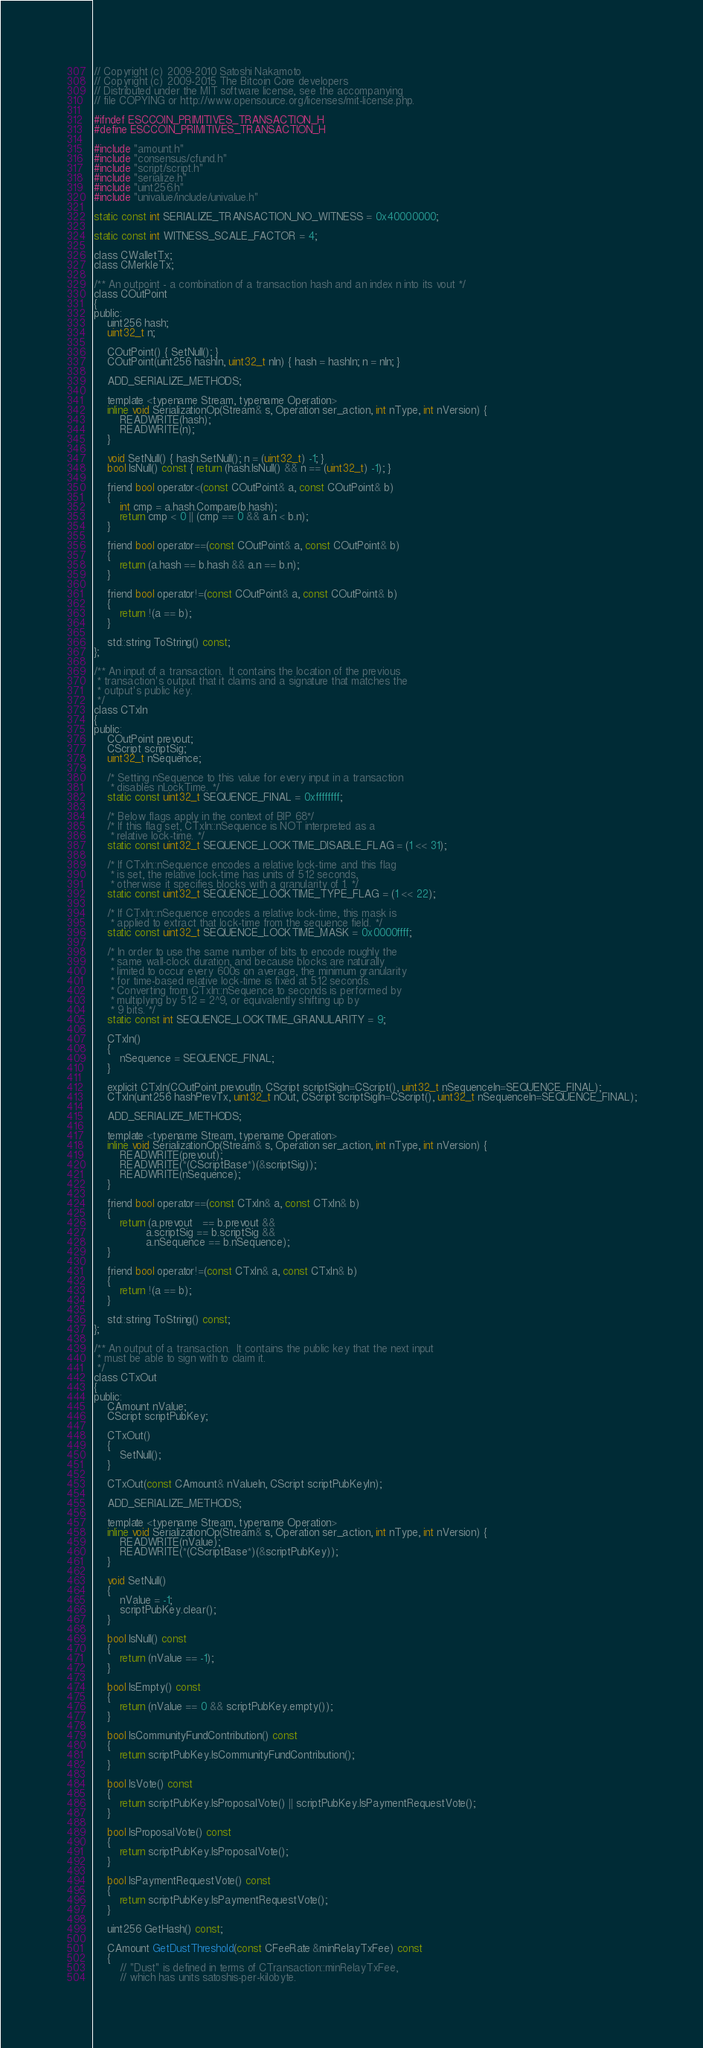Convert code to text. <code><loc_0><loc_0><loc_500><loc_500><_C_>// Copyright (c) 2009-2010 Satoshi Nakamoto
// Copyright (c) 2009-2015 The Bitcoin Core developers
// Distributed under the MIT software license, see the accompanying
// file COPYING or http://www.opensource.org/licenses/mit-license.php.

#ifndef ESCCOIN_PRIMITIVES_TRANSACTION_H
#define ESCCOIN_PRIMITIVES_TRANSACTION_H

#include "amount.h"
#include "consensus/cfund.h"
#include "script/script.h"
#include "serialize.h"
#include "uint256.h"
#include "univalue/include/univalue.h"

static const int SERIALIZE_TRANSACTION_NO_WITNESS = 0x40000000;

static const int WITNESS_SCALE_FACTOR = 4;

class CWalletTx;
class CMerkleTx;

/** An outpoint - a combination of a transaction hash and an index n into its vout */
class COutPoint
{
public:
    uint256 hash;
    uint32_t n;

    COutPoint() { SetNull(); }
    COutPoint(uint256 hashIn, uint32_t nIn) { hash = hashIn; n = nIn; }

    ADD_SERIALIZE_METHODS;

    template <typename Stream, typename Operation>
    inline void SerializationOp(Stream& s, Operation ser_action, int nType, int nVersion) {
        READWRITE(hash);
        READWRITE(n);
    }

    void SetNull() { hash.SetNull(); n = (uint32_t) -1; }
    bool IsNull() const { return (hash.IsNull() && n == (uint32_t) -1); }

    friend bool operator<(const COutPoint& a, const COutPoint& b)
    {
        int cmp = a.hash.Compare(b.hash);
        return cmp < 0 || (cmp == 0 && a.n < b.n);
    }

    friend bool operator==(const COutPoint& a, const COutPoint& b)
    {
        return (a.hash == b.hash && a.n == b.n);
    }

    friend bool operator!=(const COutPoint& a, const COutPoint& b)
    {
        return !(a == b);
    }

    std::string ToString() const;
};

/** An input of a transaction.  It contains the location of the previous
 * transaction's output that it claims and a signature that matches the
 * output's public key.
 */
class CTxIn
{
public:
    COutPoint prevout;
    CScript scriptSig;
    uint32_t nSequence;

    /* Setting nSequence to this value for every input in a transaction
     * disables nLockTime. */
    static const uint32_t SEQUENCE_FINAL = 0xffffffff;

    /* Below flags apply in the context of BIP 68*/
    /* If this flag set, CTxIn::nSequence is NOT interpreted as a
     * relative lock-time. */
    static const uint32_t SEQUENCE_LOCKTIME_DISABLE_FLAG = (1 << 31);

    /* If CTxIn::nSequence encodes a relative lock-time and this flag
     * is set, the relative lock-time has units of 512 seconds,
     * otherwise it specifies blocks with a granularity of 1. */
    static const uint32_t SEQUENCE_LOCKTIME_TYPE_FLAG = (1 << 22);

    /* If CTxIn::nSequence encodes a relative lock-time, this mask is
     * applied to extract that lock-time from the sequence field. */
    static const uint32_t SEQUENCE_LOCKTIME_MASK = 0x0000ffff;

    /* In order to use the same number of bits to encode roughly the
     * same wall-clock duration, and because blocks are naturally
     * limited to occur every 600s on average, the minimum granularity
     * for time-based relative lock-time is fixed at 512 seconds.
     * Converting from CTxIn::nSequence to seconds is performed by
     * multiplying by 512 = 2^9, or equivalently shifting up by
     * 9 bits. */
    static const int SEQUENCE_LOCKTIME_GRANULARITY = 9;

    CTxIn()
    {
        nSequence = SEQUENCE_FINAL;
    }

    explicit CTxIn(COutPoint prevoutIn, CScript scriptSigIn=CScript(), uint32_t nSequenceIn=SEQUENCE_FINAL);
    CTxIn(uint256 hashPrevTx, uint32_t nOut, CScript scriptSigIn=CScript(), uint32_t nSequenceIn=SEQUENCE_FINAL);

    ADD_SERIALIZE_METHODS;

    template <typename Stream, typename Operation>
    inline void SerializationOp(Stream& s, Operation ser_action, int nType, int nVersion) {
        READWRITE(prevout);
        READWRITE(*(CScriptBase*)(&scriptSig));
        READWRITE(nSequence);
    }

    friend bool operator==(const CTxIn& a, const CTxIn& b)
    {
        return (a.prevout   == b.prevout &&
                a.scriptSig == b.scriptSig &&
                a.nSequence == b.nSequence);
    }

    friend bool operator!=(const CTxIn& a, const CTxIn& b)
    {
        return !(a == b);
    }

    std::string ToString() const;
};

/** An output of a transaction.  It contains the public key that the next input
 * must be able to sign with to claim it.
 */
class CTxOut
{
public:
    CAmount nValue;
    CScript scriptPubKey;

    CTxOut()
    {
        SetNull();
    }

    CTxOut(const CAmount& nValueIn, CScript scriptPubKeyIn);

    ADD_SERIALIZE_METHODS;

    template <typename Stream, typename Operation>
    inline void SerializationOp(Stream& s, Operation ser_action, int nType, int nVersion) {
        READWRITE(nValue);
        READWRITE(*(CScriptBase*)(&scriptPubKey));
    }

    void SetNull()
    {
        nValue = -1;
        scriptPubKey.clear();
    }

    bool IsNull() const
    {
        return (nValue == -1);
    }

    bool IsEmpty() const
    {
        return (nValue == 0 && scriptPubKey.empty());
    }

    bool IsCommunityFundContribution() const
    {
        return scriptPubKey.IsCommunityFundContribution();
    }

    bool IsVote() const
    {
        return scriptPubKey.IsProposalVote() || scriptPubKey.IsPaymentRequestVote();
    }

    bool IsProposalVote() const
    {
        return scriptPubKey.IsProposalVote();
    }

    bool IsPaymentRequestVote() const
    {
        return scriptPubKey.IsPaymentRequestVote();
    }

    uint256 GetHash() const;

    CAmount GetDustThreshold(const CFeeRate &minRelayTxFee) const
    {
        // "Dust" is defined in terms of CTransaction::minRelayTxFee,
        // which has units satoshis-per-kilobyte.</code> 